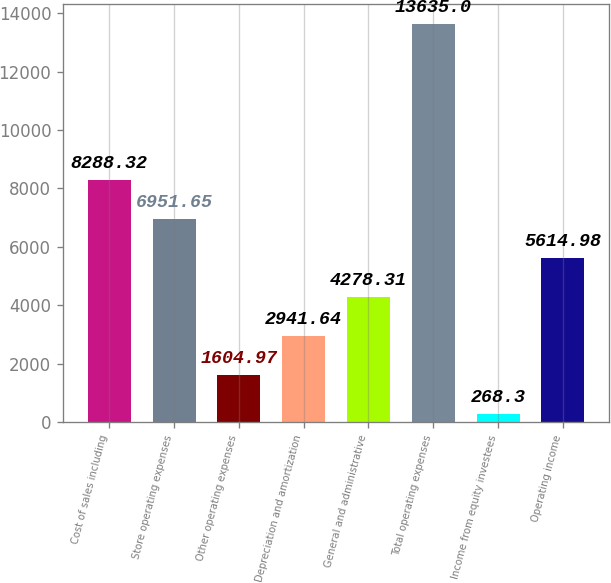Convert chart to OTSL. <chart><loc_0><loc_0><loc_500><loc_500><bar_chart><fcel>Cost of sales including<fcel>Store operating expenses<fcel>Other operating expenses<fcel>Depreciation and amortization<fcel>General and administrative<fcel>Total operating expenses<fcel>Income from equity investees<fcel>Operating income<nl><fcel>8288.32<fcel>6951.65<fcel>1604.97<fcel>2941.64<fcel>4278.31<fcel>13635<fcel>268.3<fcel>5614.98<nl></chart> 